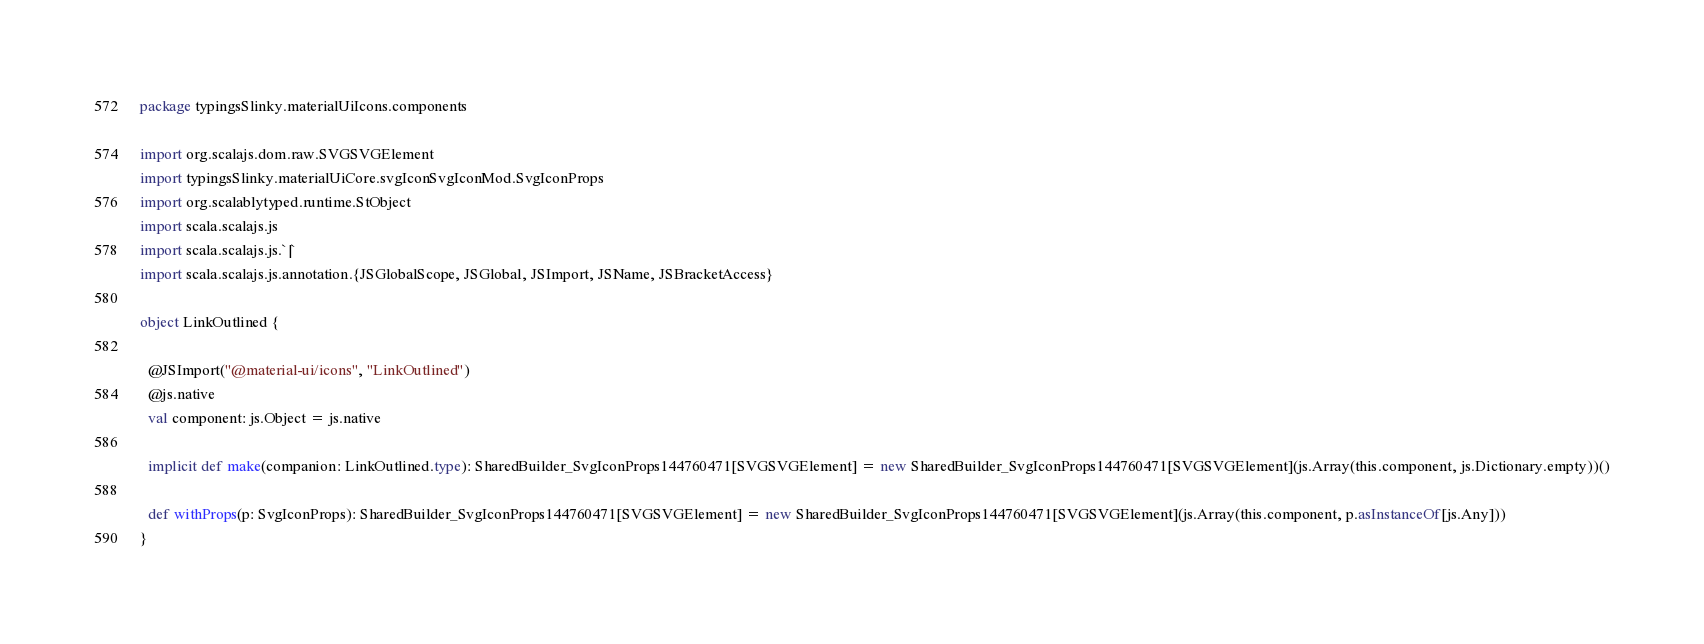Convert code to text. <code><loc_0><loc_0><loc_500><loc_500><_Scala_>package typingsSlinky.materialUiIcons.components

import org.scalajs.dom.raw.SVGSVGElement
import typingsSlinky.materialUiCore.svgIconSvgIconMod.SvgIconProps
import org.scalablytyped.runtime.StObject
import scala.scalajs.js
import scala.scalajs.js.`|`
import scala.scalajs.js.annotation.{JSGlobalScope, JSGlobal, JSImport, JSName, JSBracketAccess}

object LinkOutlined {
  
  @JSImport("@material-ui/icons", "LinkOutlined")
  @js.native
  val component: js.Object = js.native
  
  implicit def make(companion: LinkOutlined.type): SharedBuilder_SvgIconProps144760471[SVGSVGElement] = new SharedBuilder_SvgIconProps144760471[SVGSVGElement](js.Array(this.component, js.Dictionary.empty))()
  
  def withProps(p: SvgIconProps): SharedBuilder_SvgIconProps144760471[SVGSVGElement] = new SharedBuilder_SvgIconProps144760471[SVGSVGElement](js.Array(this.component, p.asInstanceOf[js.Any]))
}
</code> 